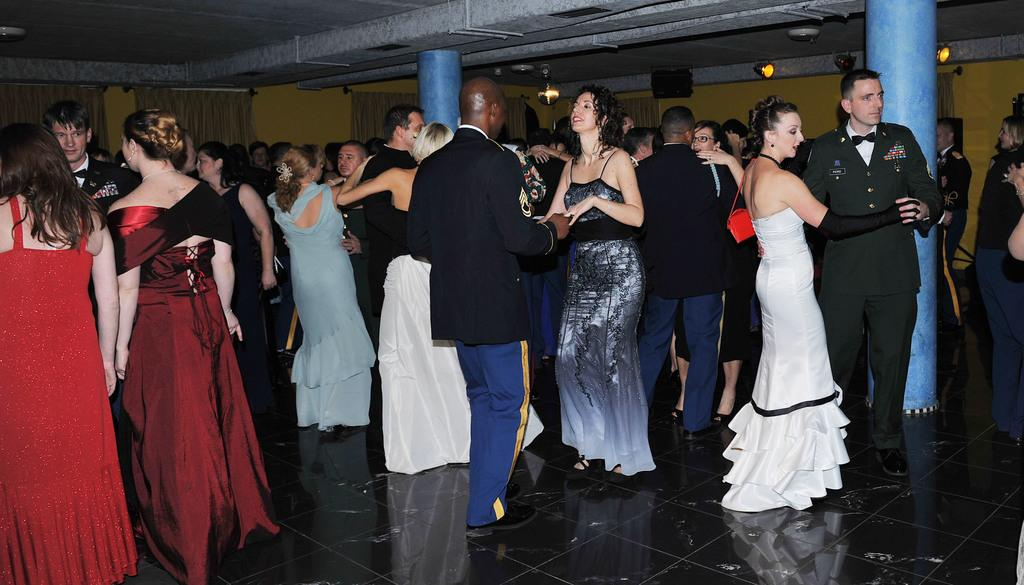What are the persons in the image doing? The persons in the image are dancing. What can be seen in the background of the image? There are lights and speakers attached to the wall in the background of the image. What type of bells can be heard ringing in the image? There are no bells present in the image, and therefore no sound can be heard. 